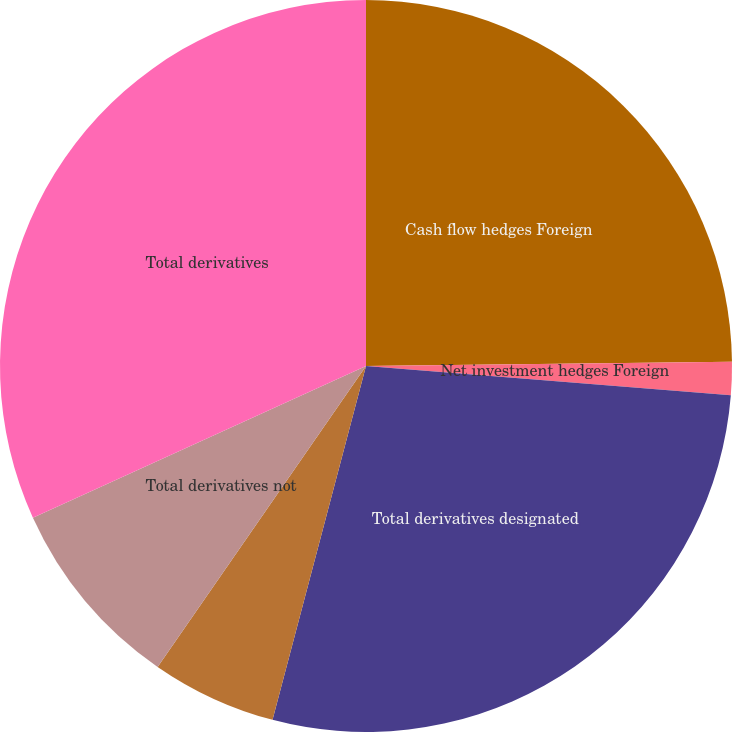Convert chart. <chart><loc_0><loc_0><loc_500><loc_500><pie_chart><fcel>Cash flow hedges Foreign<fcel>Net investment hedges Foreign<fcel>Total derivatives designated<fcel>Foreign exchange contracts<fcel>Total derivatives not<fcel>Total derivatives<nl><fcel>24.81%<fcel>1.46%<fcel>27.84%<fcel>5.53%<fcel>8.56%<fcel>31.8%<nl></chart> 